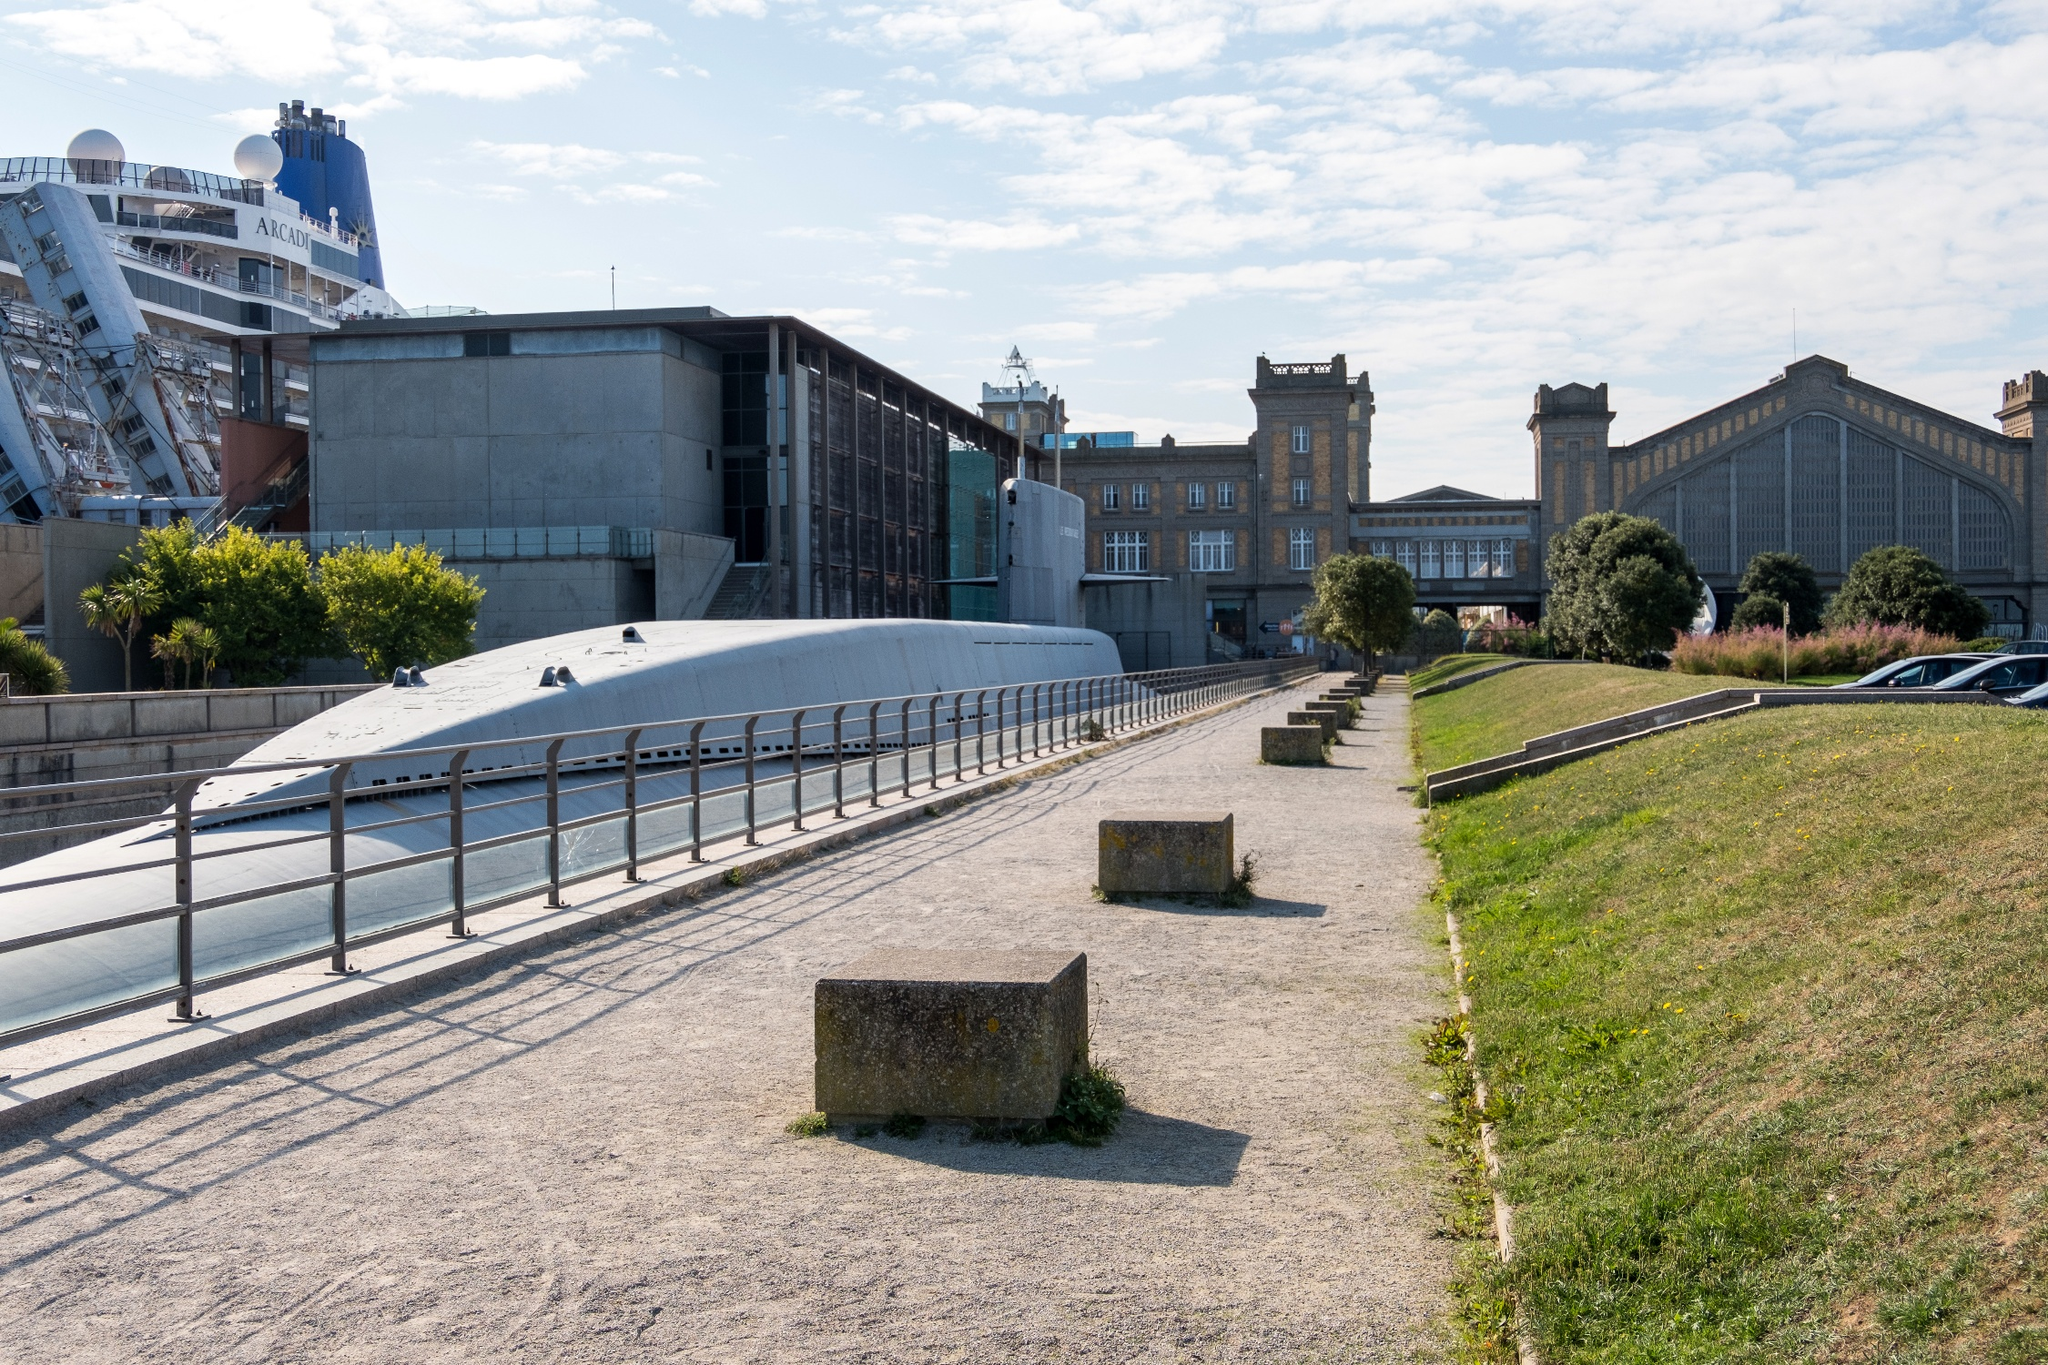How busy does the area appear in this image? The area appears relatively quiet and unbusy at the time the photo was taken. The pedestrian walkway shows few people, suggesting a peaceful and perhaps less frequented moment. However, the presence of the large cruise ship indicates that the area can often be bustling with tourists during docking periods. The tranquil ambiance is underscored by the clear blue sky and ample open space, making it an inviting spot for relaxation. 